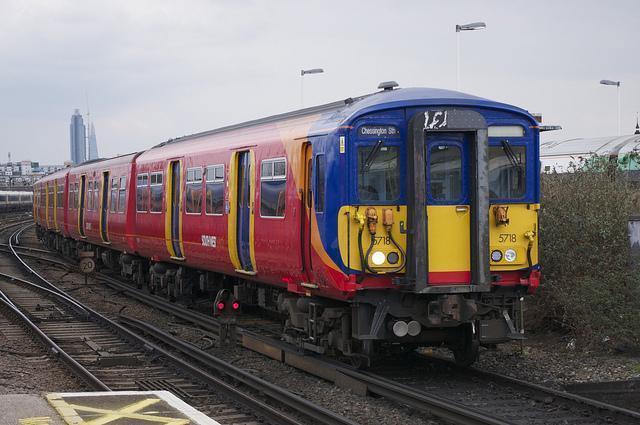How many baby elephants are there?
Give a very brief answer. 0. 